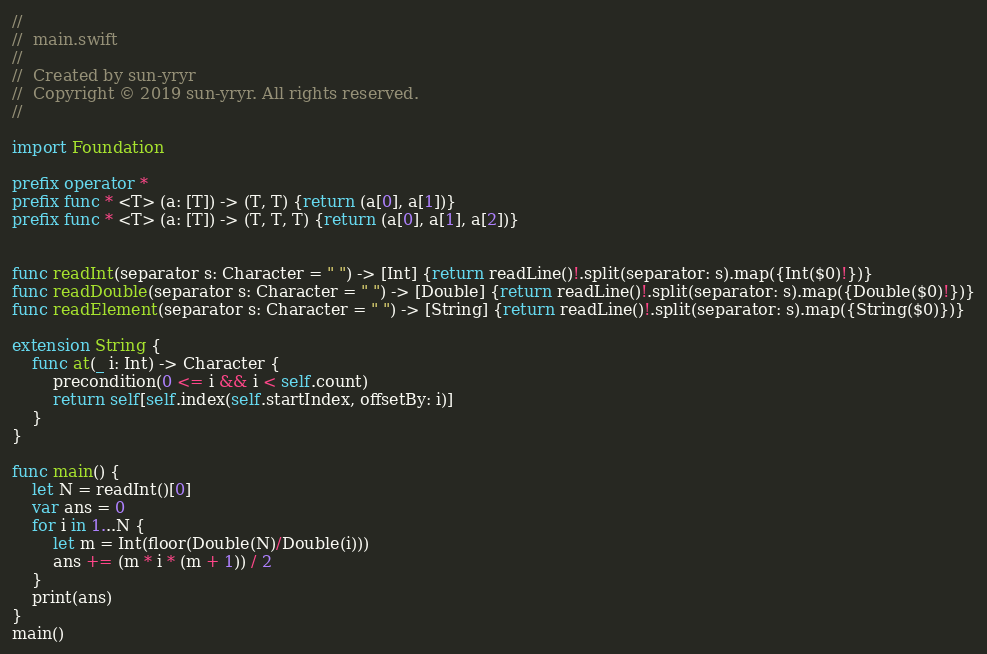Convert code to text. <code><loc_0><loc_0><loc_500><loc_500><_Swift_>//
//  main.swift
//
//  Created by sun-yryr
//  Copyright © 2019 sun-yryr. All rights reserved.
//

import Foundation

prefix operator *
prefix func * <T> (a: [T]) -> (T, T) {return (a[0], a[1])}
prefix func * <T> (a: [T]) -> (T, T, T) {return (a[0], a[1], a[2])}


func readInt(separator s: Character = " ") -> [Int] {return readLine()!.split(separator: s).map({Int($0)!})}
func readDouble(separator s: Character = " ") -> [Double] {return readLine()!.split(separator: s).map({Double($0)!})}
func readElement(separator s: Character = " ") -> [String] {return readLine()!.split(separator: s).map({String($0)})}

extension String {
    func at(_ i: Int) -> Character {
        precondition(0 <= i && i < self.count)
        return self[self.index(self.startIndex, offsetBy: i)]
    }
}

func main() {
    let N = readInt()[0]
    var ans = 0
    for i in 1...N {
        let m = Int(floor(Double(N)/Double(i)))
        ans += (m * i * (m + 1)) / 2
    }
    print(ans)
}
main()
</code> 